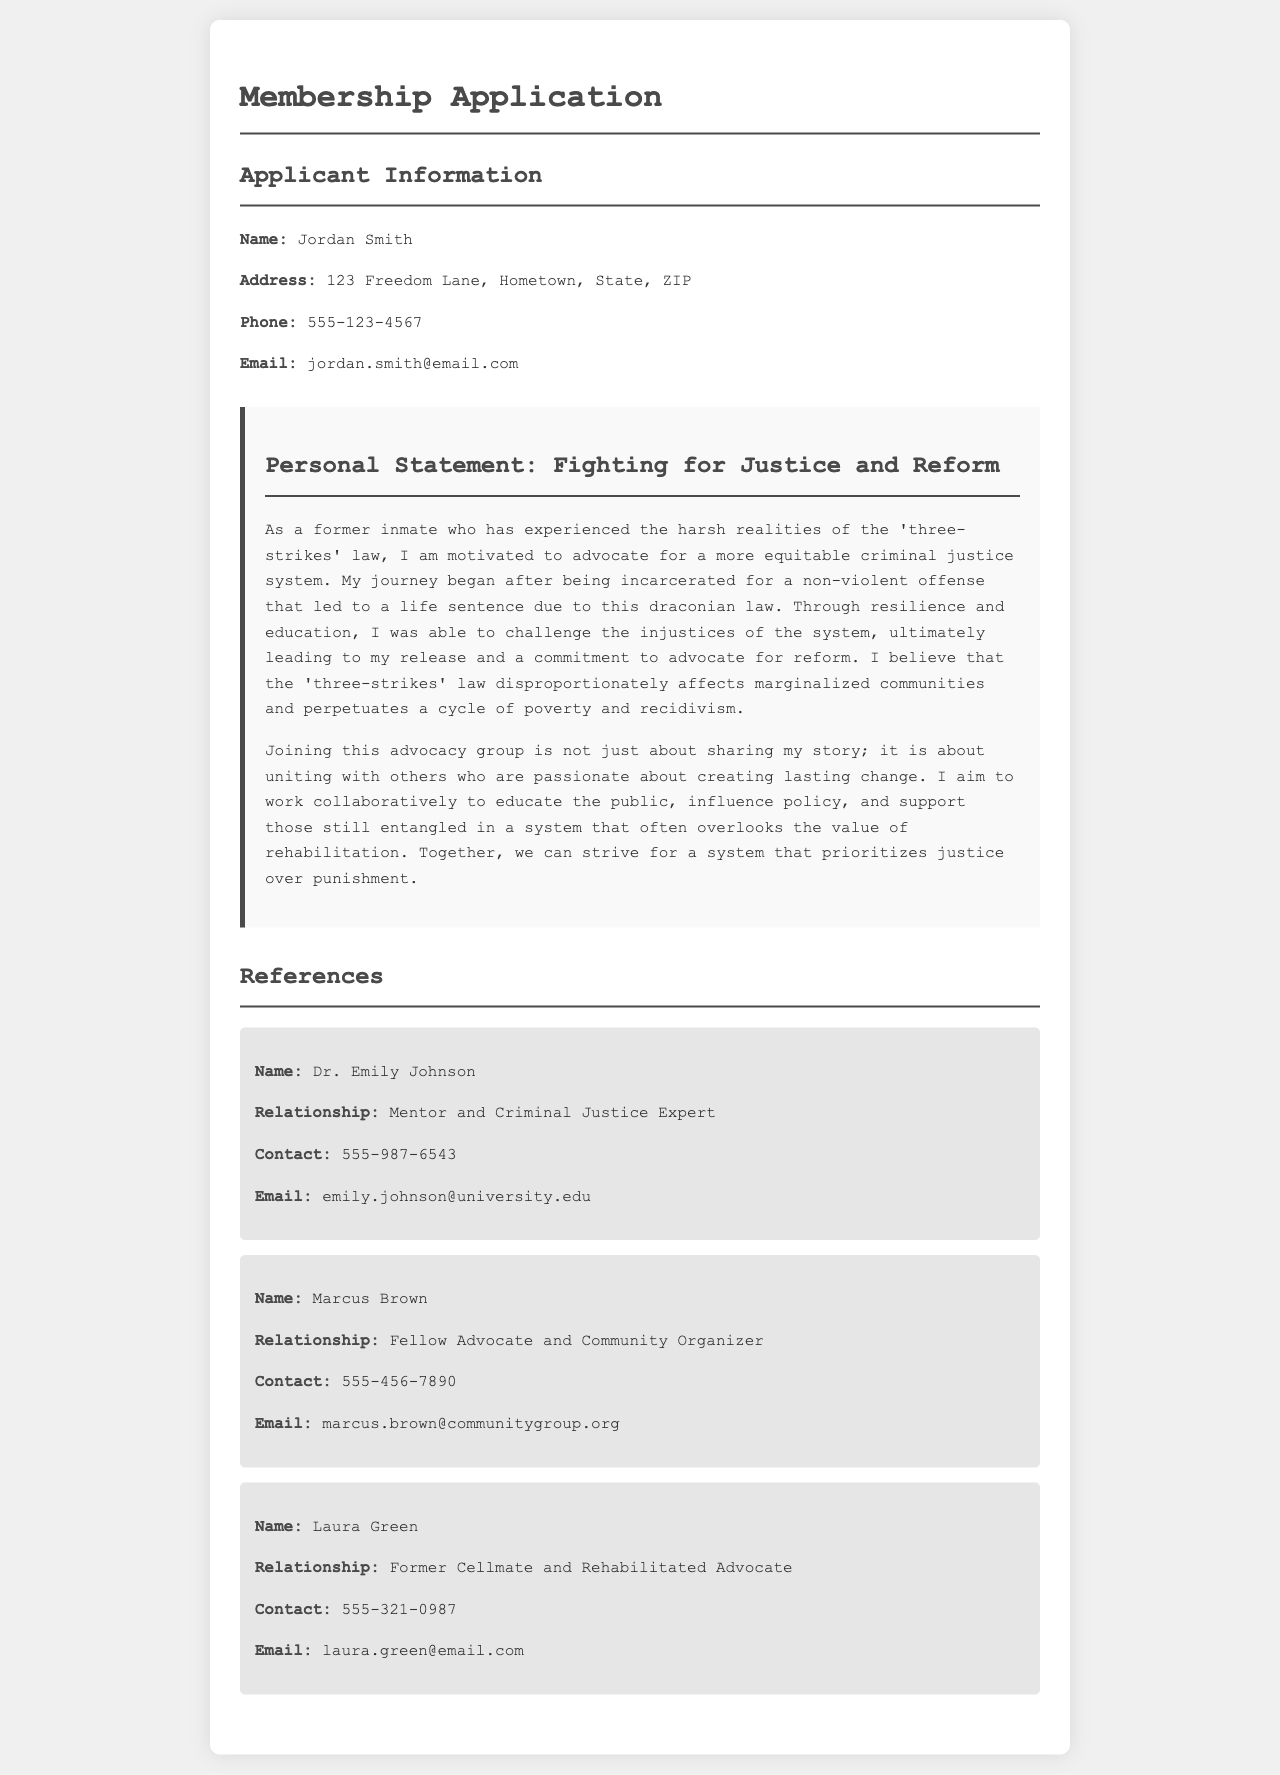What is the applicant's name? The applicant's name is stated in the personal information section.
Answer: Jordan Smith What is the applicant's email address? The email address is indicated in the personal information section.
Answer: jordan.smith@email.com What law does the applicant focus on advocating against? The law mentioned is referenced in the personal statement regarding the applicant's background.
Answer: three-strikes law Who is Dr. Emily Johnson? Dr. Emily Johnson is mentioned as a reference along with their relationship to the applicant.
Answer: Mentor and Criminal Justice Expert What does the applicant believe the 'three-strikes' law affects disproportionately? The statement indicates a specific group impacted by this law.
Answer: marginalized communities How many references are provided in total? The number of references can be counted in the references section of the document.
Answer: Three What is the purpose of joining the advocacy group as stated by the applicant? The purpose is outlined in the personal statement, which summarizes their intentions.
Answer: Creating lasting change What is the phone number of Marcus Brown? The phone number can be found in the reference section under Marcus Brown’s information.
Answer: 555-456-7890 